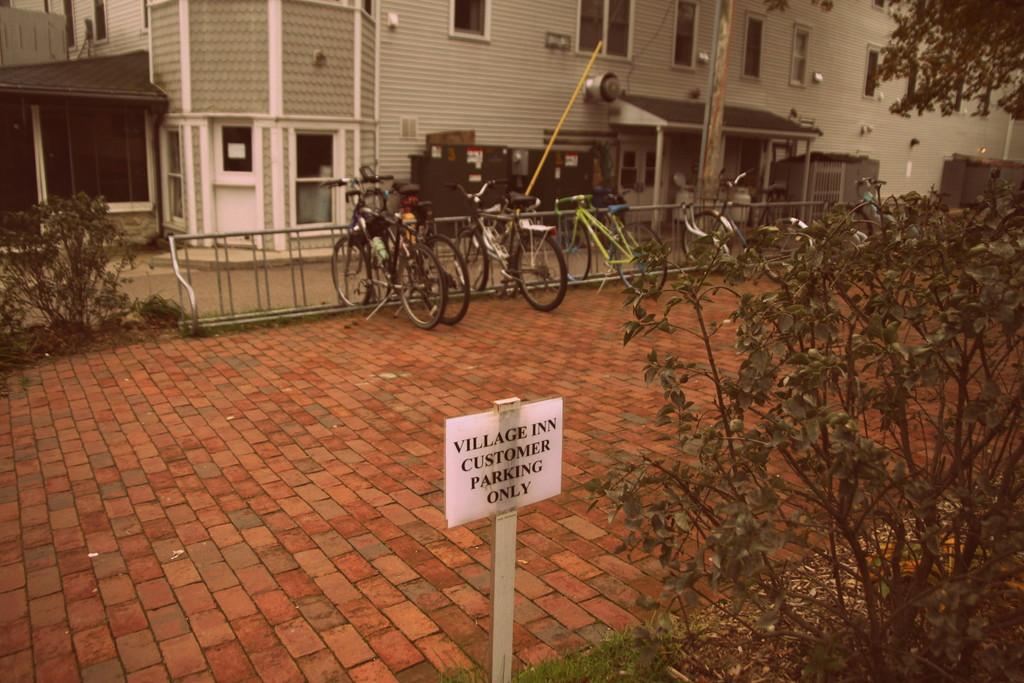What type of structure is visible at the top of the image? There is a building in the image, located at the top. What can be seen in the middle of the image? There are bicycles in the middle of the image. What type of vegetation is on the right side of the image? There are plants on the right side of the image. What type of vegetation is on the left side of the image? There are trees on the left side of the image. Where is the store located in the image? There is no store present in the image. What type of wind can be seen blowing through the image? There is no wind visible in the image, and the term "zephyr" refers to a gentle breeze, which cannot be seen. 